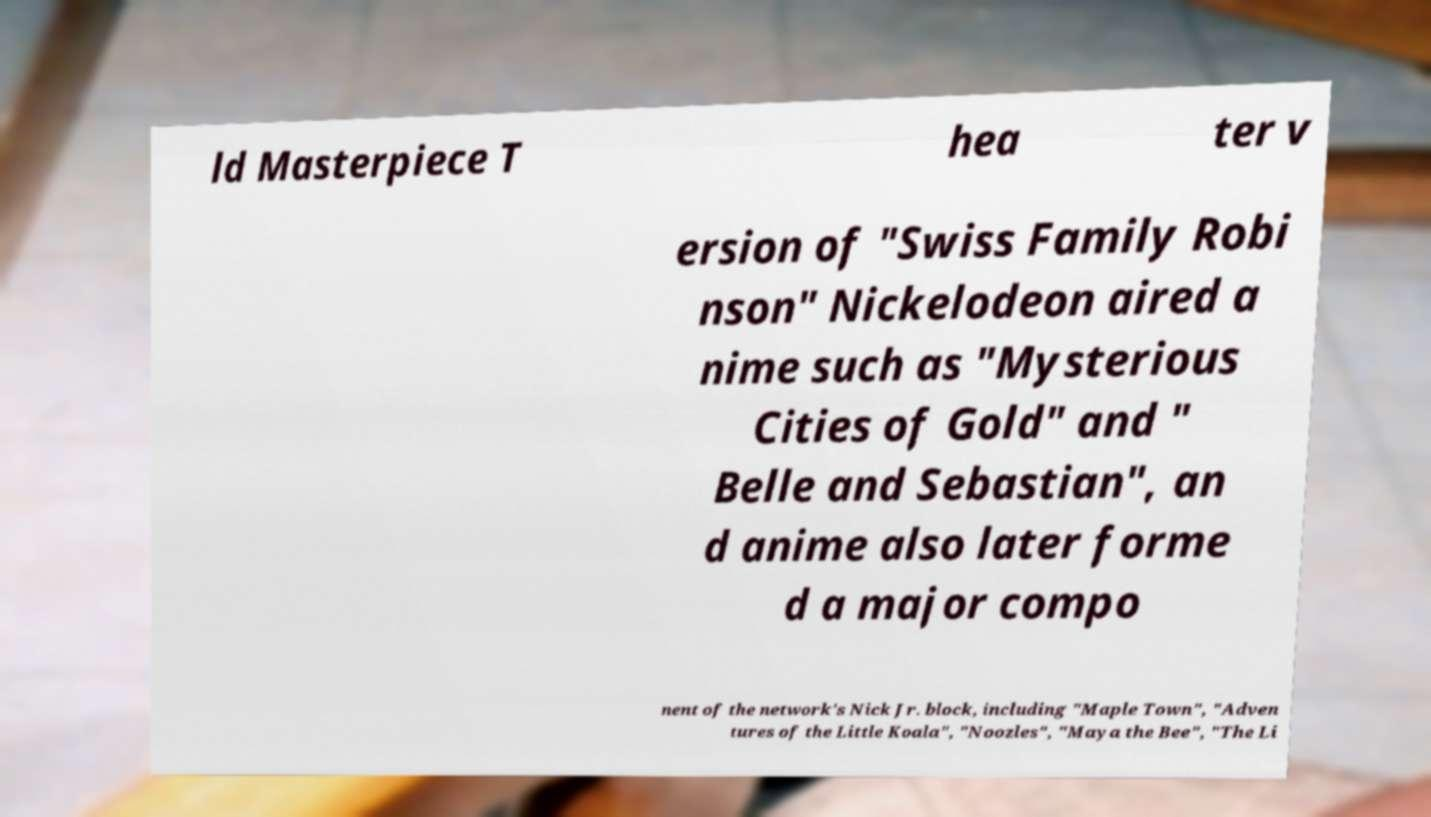I need the written content from this picture converted into text. Can you do that? ld Masterpiece T hea ter v ersion of "Swiss Family Robi nson" Nickelodeon aired a nime such as "Mysterious Cities of Gold" and " Belle and Sebastian", an d anime also later forme d a major compo nent of the network's Nick Jr. block, including "Maple Town", "Adven tures of the Little Koala", "Noozles", "Maya the Bee", "The Li 